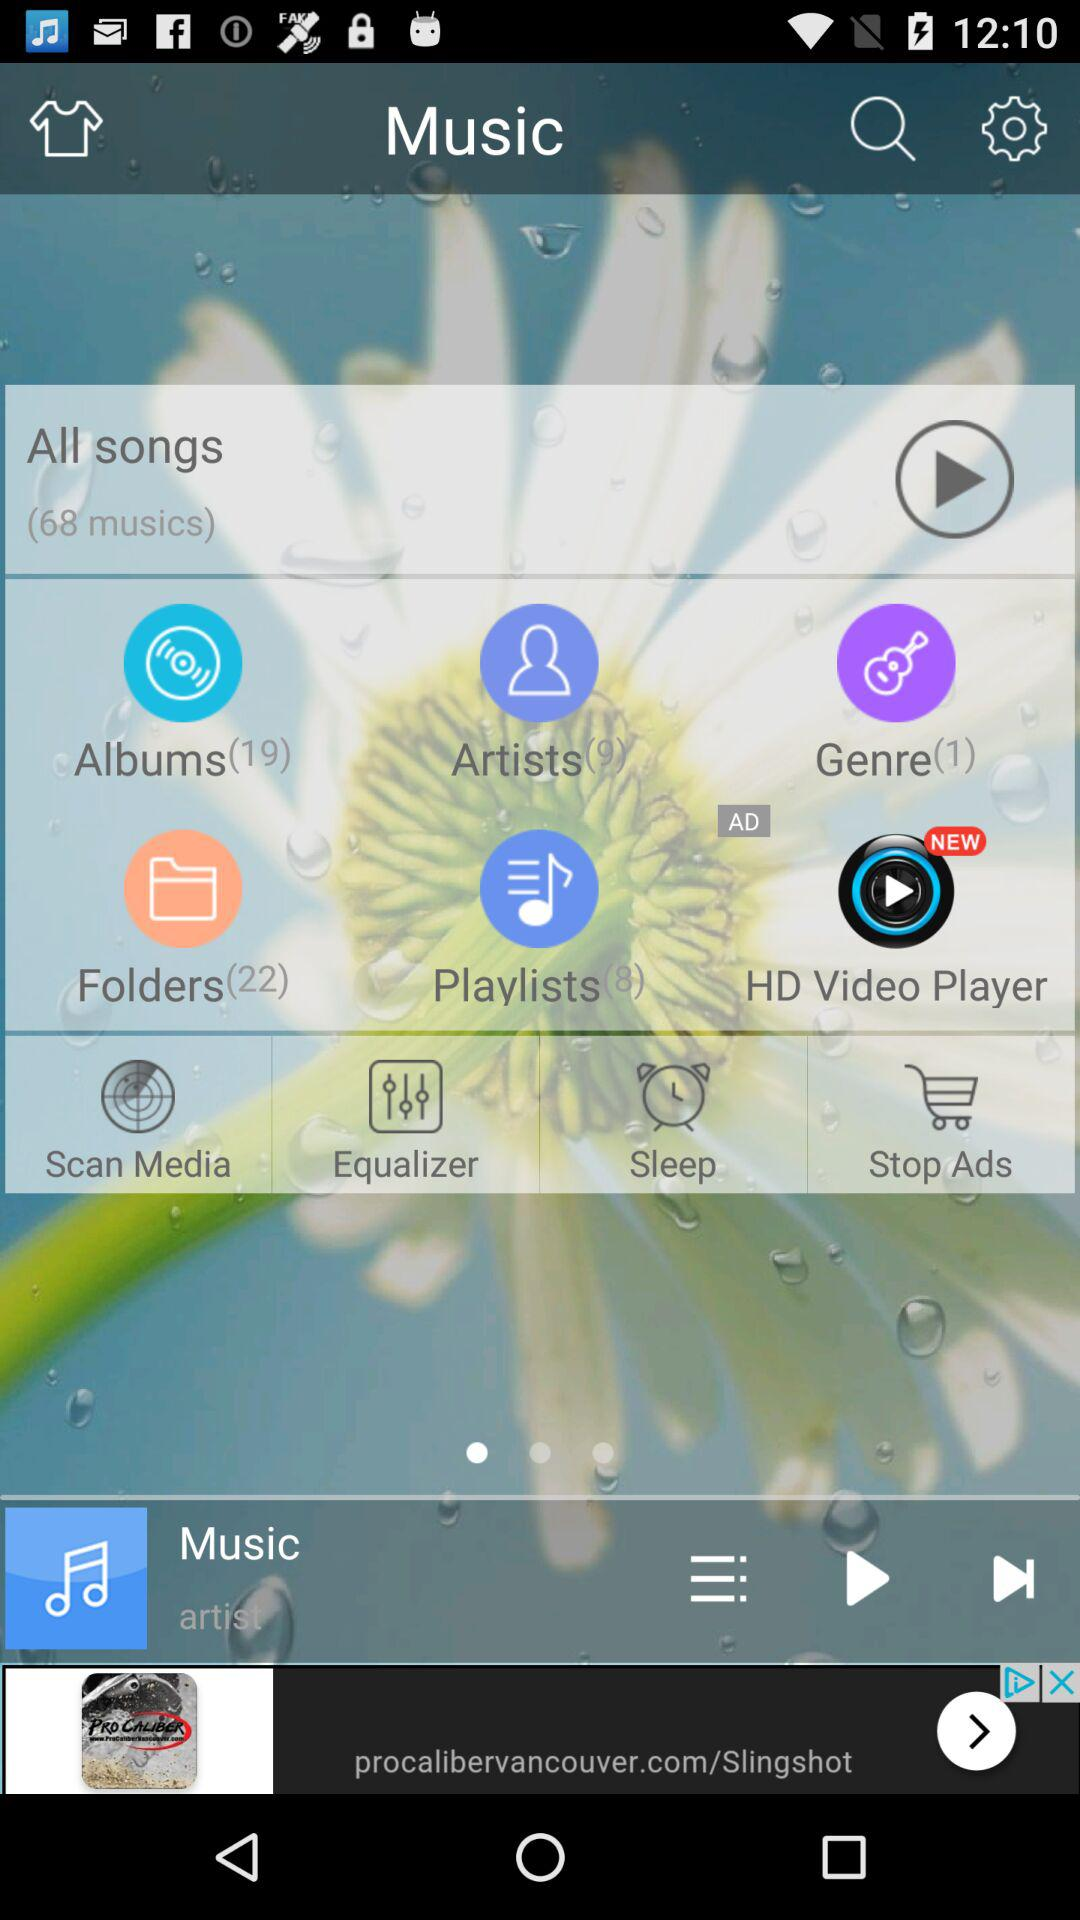What is the number of albums? The number of albums is 19. 